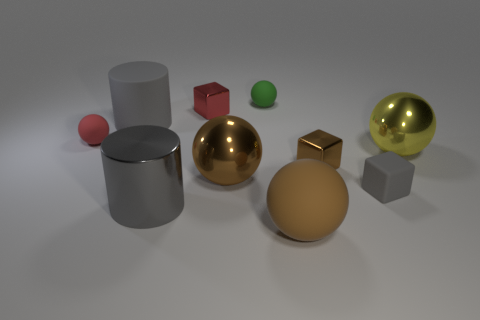Subtract 2 balls. How many balls are left? 3 Subtract all small metal blocks. How many blocks are left? 1 Subtract all yellow spheres. How many spheres are left? 4 Subtract all red spheres. Subtract all red blocks. How many spheres are left? 4 Subtract all cylinders. How many objects are left? 8 Add 2 tiny purple rubber balls. How many tiny purple rubber balls exist? 2 Subtract 0 purple cylinders. How many objects are left? 10 Subtract all small yellow metal blocks. Subtract all matte objects. How many objects are left? 5 Add 9 red balls. How many red balls are left? 10 